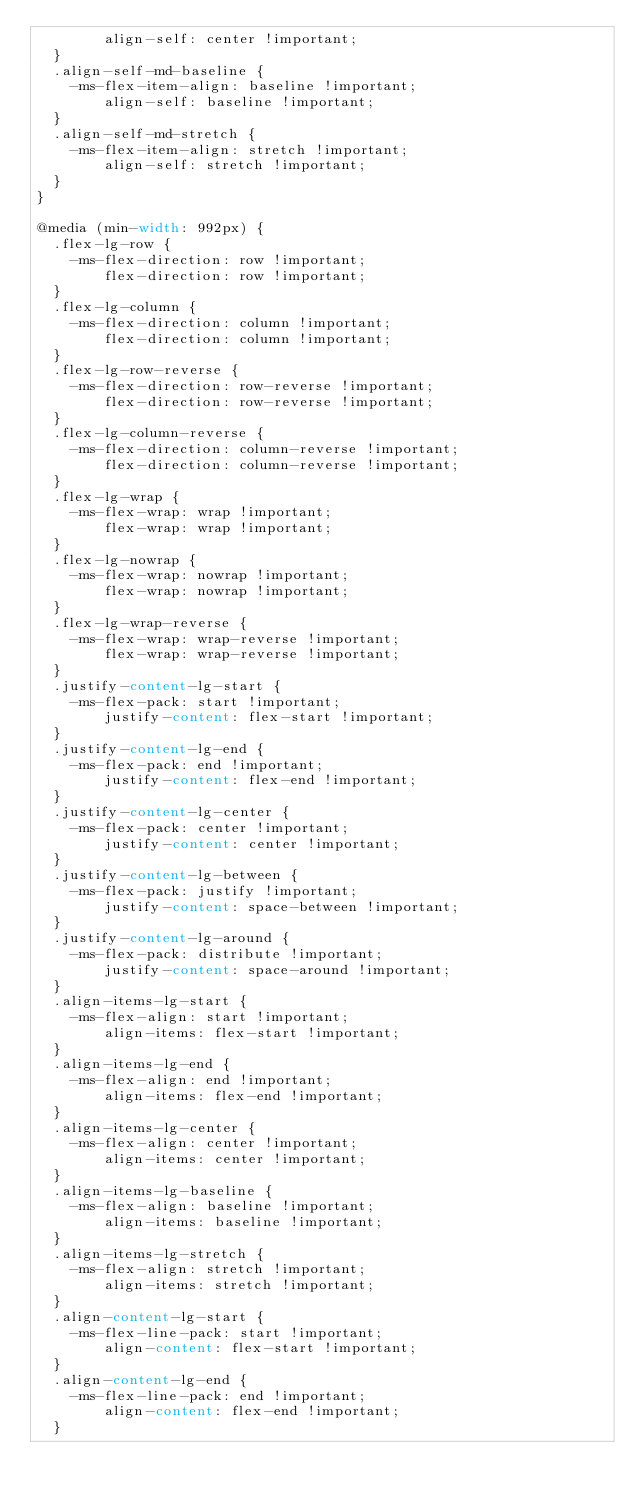<code> <loc_0><loc_0><loc_500><loc_500><_CSS_>        align-self: center !important;
  }
  .align-self-md-baseline {
    -ms-flex-item-align: baseline !important;
        align-self: baseline !important;
  }
  .align-self-md-stretch {
    -ms-flex-item-align: stretch !important;
        align-self: stretch !important;
  }
}

@media (min-width: 992px) {
  .flex-lg-row {
    -ms-flex-direction: row !important;
        flex-direction: row !important;
  }
  .flex-lg-column {
    -ms-flex-direction: column !important;
        flex-direction: column !important;
  }
  .flex-lg-row-reverse {
    -ms-flex-direction: row-reverse !important;
        flex-direction: row-reverse !important;
  }
  .flex-lg-column-reverse {
    -ms-flex-direction: column-reverse !important;
        flex-direction: column-reverse !important;
  }
  .flex-lg-wrap {
    -ms-flex-wrap: wrap !important;
        flex-wrap: wrap !important;
  }
  .flex-lg-nowrap {
    -ms-flex-wrap: nowrap !important;
        flex-wrap: nowrap !important;
  }
  .flex-lg-wrap-reverse {
    -ms-flex-wrap: wrap-reverse !important;
        flex-wrap: wrap-reverse !important;
  }
  .justify-content-lg-start {
    -ms-flex-pack: start !important;
        justify-content: flex-start !important;
  }
  .justify-content-lg-end {
    -ms-flex-pack: end !important;
        justify-content: flex-end !important;
  }
  .justify-content-lg-center {
    -ms-flex-pack: center !important;
        justify-content: center !important;
  }
  .justify-content-lg-between {
    -ms-flex-pack: justify !important;
        justify-content: space-between !important;
  }
  .justify-content-lg-around {
    -ms-flex-pack: distribute !important;
        justify-content: space-around !important;
  }
  .align-items-lg-start {
    -ms-flex-align: start !important;
        align-items: flex-start !important;
  }
  .align-items-lg-end {
    -ms-flex-align: end !important;
        align-items: flex-end !important;
  }
  .align-items-lg-center {
    -ms-flex-align: center !important;
        align-items: center !important;
  }
  .align-items-lg-baseline {
    -ms-flex-align: baseline !important;
        align-items: baseline !important;
  }
  .align-items-lg-stretch {
    -ms-flex-align: stretch !important;
        align-items: stretch !important;
  }
  .align-content-lg-start {
    -ms-flex-line-pack: start !important;
        align-content: flex-start !important;
  }
  .align-content-lg-end {
    -ms-flex-line-pack: end !important;
        align-content: flex-end !important;
  }</code> 